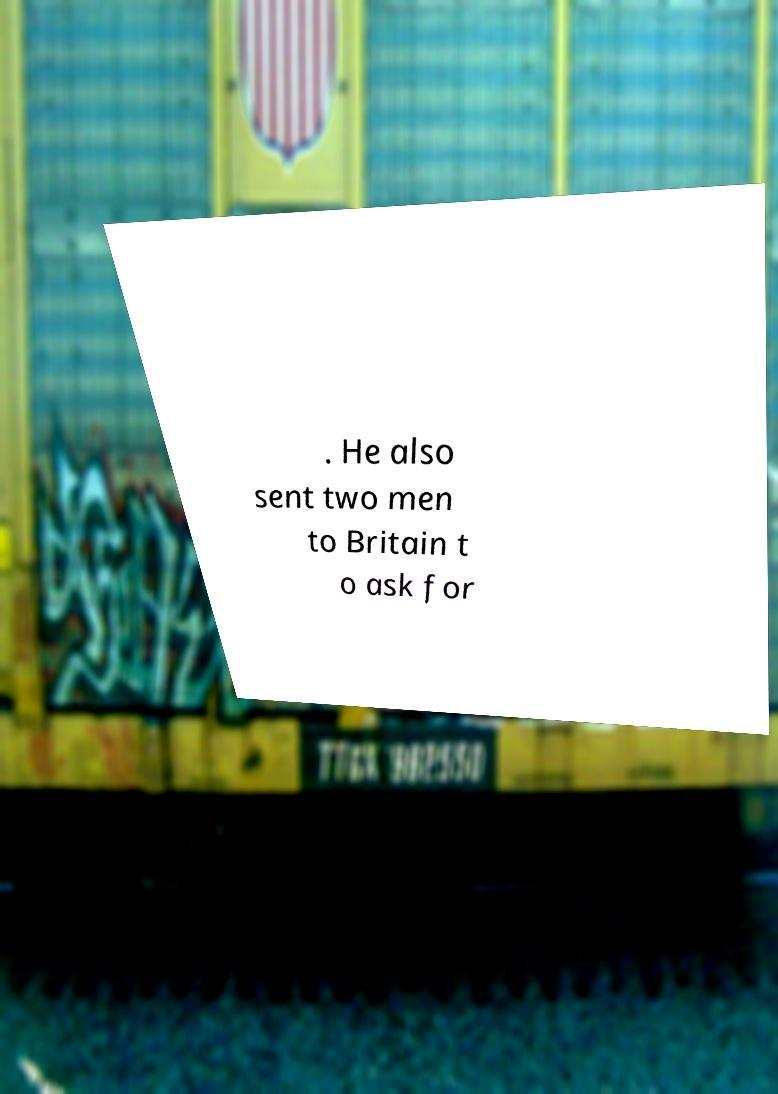Please identify and transcribe the text found in this image. . He also sent two men to Britain t o ask for 